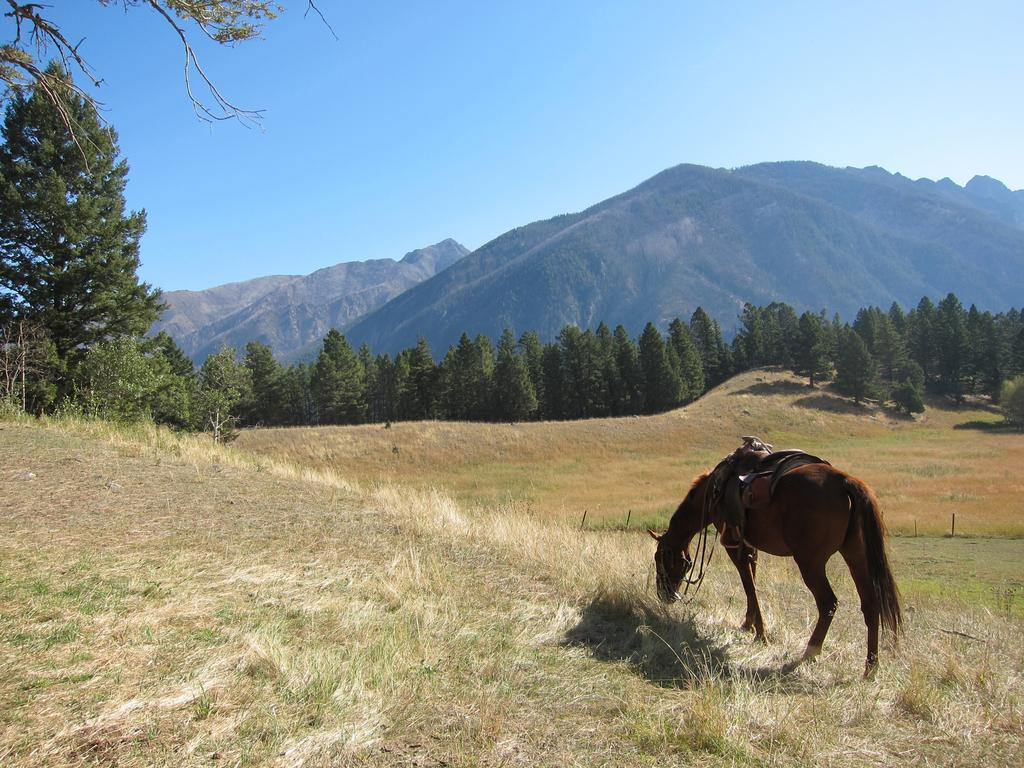What animal can be seen on the right side of the image? There is a horse on the right side of the image. What type of terrain is visible in the image? There is grass on the ground and trees visible in the image. What geographical feature can be seen in the background of the image? There are mountains in the image. What color is the sky at the top of the image? The sky is blue at the top of the image. What type of spoon is being used to trade on the road in the image? There is no spoon, trade, or road present in the image. 